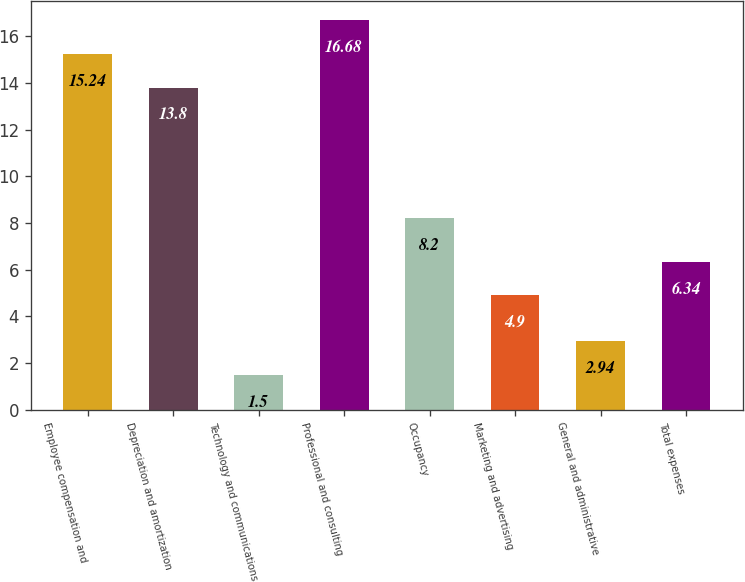<chart> <loc_0><loc_0><loc_500><loc_500><bar_chart><fcel>Employee compensation and<fcel>Depreciation and amortization<fcel>Technology and communications<fcel>Professional and consulting<fcel>Occupancy<fcel>Marketing and advertising<fcel>General and administrative<fcel>Total expenses<nl><fcel>15.24<fcel>13.8<fcel>1.5<fcel>16.68<fcel>8.2<fcel>4.9<fcel>2.94<fcel>6.34<nl></chart> 